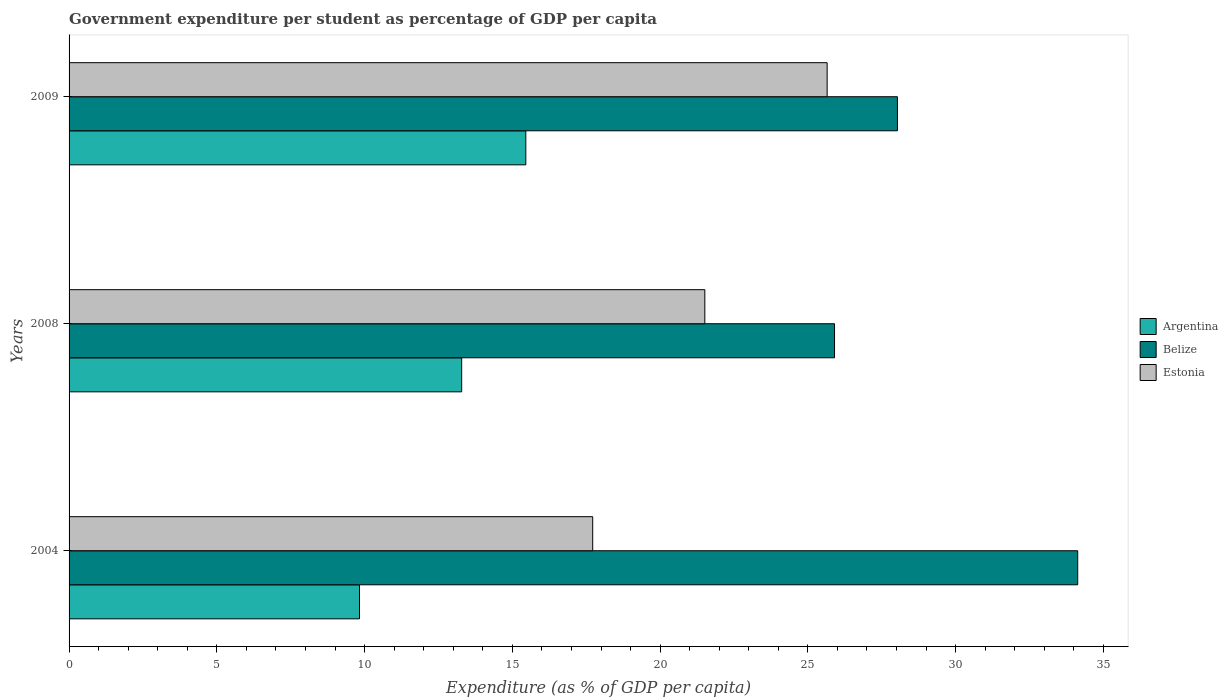How many different coloured bars are there?
Your response must be concise. 3. How many groups of bars are there?
Offer a very short reply. 3. Are the number of bars per tick equal to the number of legend labels?
Your answer should be very brief. Yes. Are the number of bars on each tick of the Y-axis equal?
Provide a short and direct response. Yes. How many bars are there on the 2nd tick from the top?
Keep it short and to the point. 3. In how many cases, is the number of bars for a given year not equal to the number of legend labels?
Give a very brief answer. 0. What is the percentage of expenditure per student in Estonia in 2009?
Your answer should be very brief. 25.65. Across all years, what is the maximum percentage of expenditure per student in Belize?
Ensure brevity in your answer.  34.13. Across all years, what is the minimum percentage of expenditure per student in Argentina?
Offer a very short reply. 9.83. What is the total percentage of expenditure per student in Argentina in the graph?
Offer a very short reply. 38.57. What is the difference between the percentage of expenditure per student in Estonia in 2004 and that in 2009?
Provide a succinct answer. -7.93. What is the difference between the percentage of expenditure per student in Estonia in 2004 and the percentage of expenditure per student in Argentina in 2008?
Offer a very short reply. 4.43. What is the average percentage of expenditure per student in Belize per year?
Your response must be concise. 29.36. In the year 2009, what is the difference between the percentage of expenditure per student in Argentina and percentage of expenditure per student in Estonia?
Give a very brief answer. -10.2. What is the ratio of the percentage of expenditure per student in Estonia in 2008 to that in 2009?
Keep it short and to the point. 0.84. Is the percentage of expenditure per student in Argentina in 2004 less than that in 2009?
Give a very brief answer. Yes. Is the difference between the percentage of expenditure per student in Argentina in 2008 and 2009 greater than the difference between the percentage of expenditure per student in Estonia in 2008 and 2009?
Your answer should be compact. Yes. What is the difference between the highest and the second highest percentage of expenditure per student in Belize?
Offer a terse response. 6.1. What is the difference between the highest and the lowest percentage of expenditure per student in Belize?
Your response must be concise. 8.23. What does the 2nd bar from the top in 2009 represents?
Provide a short and direct response. Belize. What does the 2nd bar from the bottom in 2008 represents?
Offer a terse response. Belize. Is it the case that in every year, the sum of the percentage of expenditure per student in Argentina and percentage of expenditure per student in Estonia is greater than the percentage of expenditure per student in Belize?
Offer a very short reply. No. How many bars are there?
Offer a very short reply. 9. How many years are there in the graph?
Give a very brief answer. 3. Does the graph contain any zero values?
Provide a short and direct response. No. Does the graph contain grids?
Give a very brief answer. No. Where does the legend appear in the graph?
Your answer should be very brief. Center right. How many legend labels are there?
Provide a short and direct response. 3. How are the legend labels stacked?
Your response must be concise. Vertical. What is the title of the graph?
Offer a very short reply. Government expenditure per student as percentage of GDP per capita. What is the label or title of the X-axis?
Offer a terse response. Expenditure (as % of GDP per capita). What is the label or title of the Y-axis?
Give a very brief answer. Years. What is the Expenditure (as % of GDP per capita) in Argentina in 2004?
Your response must be concise. 9.83. What is the Expenditure (as % of GDP per capita) in Belize in 2004?
Your response must be concise. 34.13. What is the Expenditure (as % of GDP per capita) of Estonia in 2004?
Provide a short and direct response. 17.72. What is the Expenditure (as % of GDP per capita) of Argentina in 2008?
Provide a succinct answer. 13.29. What is the Expenditure (as % of GDP per capita) in Belize in 2008?
Your answer should be compact. 25.9. What is the Expenditure (as % of GDP per capita) of Estonia in 2008?
Make the answer very short. 21.51. What is the Expenditure (as % of GDP per capita) of Argentina in 2009?
Provide a succinct answer. 15.46. What is the Expenditure (as % of GDP per capita) of Belize in 2009?
Your response must be concise. 28.03. What is the Expenditure (as % of GDP per capita) of Estonia in 2009?
Provide a short and direct response. 25.65. Across all years, what is the maximum Expenditure (as % of GDP per capita) in Argentina?
Ensure brevity in your answer.  15.46. Across all years, what is the maximum Expenditure (as % of GDP per capita) in Belize?
Offer a terse response. 34.13. Across all years, what is the maximum Expenditure (as % of GDP per capita) of Estonia?
Your answer should be very brief. 25.65. Across all years, what is the minimum Expenditure (as % of GDP per capita) of Argentina?
Your answer should be compact. 9.83. Across all years, what is the minimum Expenditure (as % of GDP per capita) of Belize?
Give a very brief answer. 25.9. Across all years, what is the minimum Expenditure (as % of GDP per capita) of Estonia?
Offer a very short reply. 17.72. What is the total Expenditure (as % of GDP per capita) of Argentina in the graph?
Provide a short and direct response. 38.57. What is the total Expenditure (as % of GDP per capita) in Belize in the graph?
Your response must be concise. 88.07. What is the total Expenditure (as % of GDP per capita) in Estonia in the graph?
Keep it short and to the point. 64.88. What is the difference between the Expenditure (as % of GDP per capita) of Argentina in 2004 and that in 2008?
Offer a very short reply. -3.46. What is the difference between the Expenditure (as % of GDP per capita) in Belize in 2004 and that in 2008?
Your answer should be very brief. 8.23. What is the difference between the Expenditure (as % of GDP per capita) of Estonia in 2004 and that in 2008?
Your answer should be compact. -3.79. What is the difference between the Expenditure (as % of GDP per capita) in Argentina in 2004 and that in 2009?
Provide a short and direct response. -5.63. What is the difference between the Expenditure (as % of GDP per capita) of Belize in 2004 and that in 2009?
Give a very brief answer. 6.1. What is the difference between the Expenditure (as % of GDP per capita) of Estonia in 2004 and that in 2009?
Ensure brevity in your answer.  -7.93. What is the difference between the Expenditure (as % of GDP per capita) of Argentina in 2008 and that in 2009?
Give a very brief answer. -2.17. What is the difference between the Expenditure (as % of GDP per capita) in Belize in 2008 and that in 2009?
Ensure brevity in your answer.  -2.13. What is the difference between the Expenditure (as % of GDP per capita) of Estonia in 2008 and that in 2009?
Provide a succinct answer. -4.14. What is the difference between the Expenditure (as % of GDP per capita) in Argentina in 2004 and the Expenditure (as % of GDP per capita) in Belize in 2008?
Your response must be concise. -16.07. What is the difference between the Expenditure (as % of GDP per capita) of Argentina in 2004 and the Expenditure (as % of GDP per capita) of Estonia in 2008?
Provide a succinct answer. -11.69. What is the difference between the Expenditure (as % of GDP per capita) of Belize in 2004 and the Expenditure (as % of GDP per capita) of Estonia in 2008?
Offer a very short reply. 12.62. What is the difference between the Expenditure (as % of GDP per capita) in Argentina in 2004 and the Expenditure (as % of GDP per capita) in Belize in 2009?
Your answer should be compact. -18.2. What is the difference between the Expenditure (as % of GDP per capita) in Argentina in 2004 and the Expenditure (as % of GDP per capita) in Estonia in 2009?
Keep it short and to the point. -15.82. What is the difference between the Expenditure (as % of GDP per capita) of Belize in 2004 and the Expenditure (as % of GDP per capita) of Estonia in 2009?
Keep it short and to the point. 8.48. What is the difference between the Expenditure (as % of GDP per capita) of Argentina in 2008 and the Expenditure (as % of GDP per capita) of Belize in 2009?
Your answer should be compact. -14.75. What is the difference between the Expenditure (as % of GDP per capita) of Argentina in 2008 and the Expenditure (as % of GDP per capita) of Estonia in 2009?
Provide a succinct answer. -12.37. What is the difference between the Expenditure (as % of GDP per capita) of Belize in 2008 and the Expenditure (as % of GDP per capita) of Estonia in 2009?
Provide a short and direct response. 0.25. What is the average Expenditure (as % of GDP per capita) in Argentina per year?
Offer a terse response. 12.86. What is the average Expenditure (as % of GDP per capita) in Belize per year?
Give a very brief answer. 29.36. What is the average Expenditure (as % of GDP per capita) of Estonia per year?
Give a very brief answer. 21.63. In the year 2004, what is the difference between the Expenditure (as % of GDP per capita) in Argentina and Expenditure (as % of GDP per capita) in Belize?
Give a very brief answer. -24.3. In the year 2004, what is the difference between the Expenditure (as % of GDP per capita) in Argentina and Expenditure (as % of GDP per capita) in Estonia?
Provide a short and direct response. -7.89. In the year 2004, what is the difference between the Expenditure (as % of GDP per capita) of Belize and Expenditure (as % of GDP per capita) of Estonia?
Your answer should be compact. 16.41. In the year 2008, what is the difference between the Expenditure (as % of GDP per capita) in Argentina and Expenditure (as % of GDP per capita) in Belize?
Provide a succinct answer. -12.62. In the year 2008, what is the difference between the Expenditure (as % of GDP per capita) in Argentina and Expenditure (as % of GDP per capita) in Estonia?
Your answer should be very brief. -8.23. In the year 2008, what is the difference between the Expenditure (as % of GDP per capita) in Belize and Expenditure (as % of GDP per capita) in Estonia?
Your response must be concise. 4.39. In the year 2009, what is the difference between the Expenditure (as % of GDP per capita) of Argentina and Expenditure (as % of GDP per capita) of Belize?
Keep it short and to the point. -12.58. In the year 2009, what is the difference between the Expenditure (as % of GDP per capita) in Argentina and Expenditure (as % of GDP per capita) in Estonia?
Your answer should be very brief. -10.2. In the year 2009, what is the difference between the Expenditure (as % of GDP per capita) in Belize and Expenditure (as % of GDP per capita) in Estonia?
Your response must be concise. 2.38. What is the ratio of the Expenditure (as % of GDP per capita) of Argentina in 2004 to that in 2008?
Offer a very short reply. 0.74. What is the ratio of the Expenditure (as % of GDP per capita) in Belize in 2004 to that in 2008?
Provide a short and direct response. 1.32. What is the ratio of the Expenditure (as % of GDP per capita) of Estonia in 2004 to that in 2008?
Offer a terse response. 0.82. What is the ratio of the Expenditure (as % of GDP per capita) in Argentina in 2004 to that in 2009?
Provide a short and direct response. 0.64. What is the ratio of the Expenditure (as % of GDP per capita) in Belize in 2004 to that in 2009?
Your answer should be compact. 1.22. What is the ratio of the Expenditure (as % of GDP per capita) in Estonia in 2004 to that in 2009?
Offer a terse response. 0.69. What is the ratio of the Expenditure (as % of GDP per capita) of Argentina in 2008 to that in 2009?
Ensure brevity in your answer.  0.86. What is the ratio of the Expenditure (as % of GDP per capita) of Belize in 2008 to that in 2009?
Your response must be concise. 0.92. What is the ratio of the Expenditure (as % of GDP per capita) of Estonia in 2008 to that in 2009?
Your answer should be very brief. 0.84. What is the difference between the highest and the second highest Expenditure (as % of GDP per capita) in Argentina?
Provide a succinct answer. 2.17. What is the difference between the highest and the second highest Expenditure (as % of GDP per capita) of Belize?
Your answer should be very brief. 6.1. What is the difference between the highest and the second highest Expenditure (as % of GDP per capita) of Estonia?
Make the answer very short. 4.14. What is the difference between the highest and the lowest Expenditure (as % of GDP per capita) in Argentina?
Give a very brief answer. 5.63. What is the difference between the highest and the lowest Expenditure (as % of GDP per capita) of Belize?
Provide a short and direct response. 8.23. What is the difference between the highest and the lowest Expenditure (as % of GDP per capita) in Estonia?
Provide a succinct answer. 7.93. 